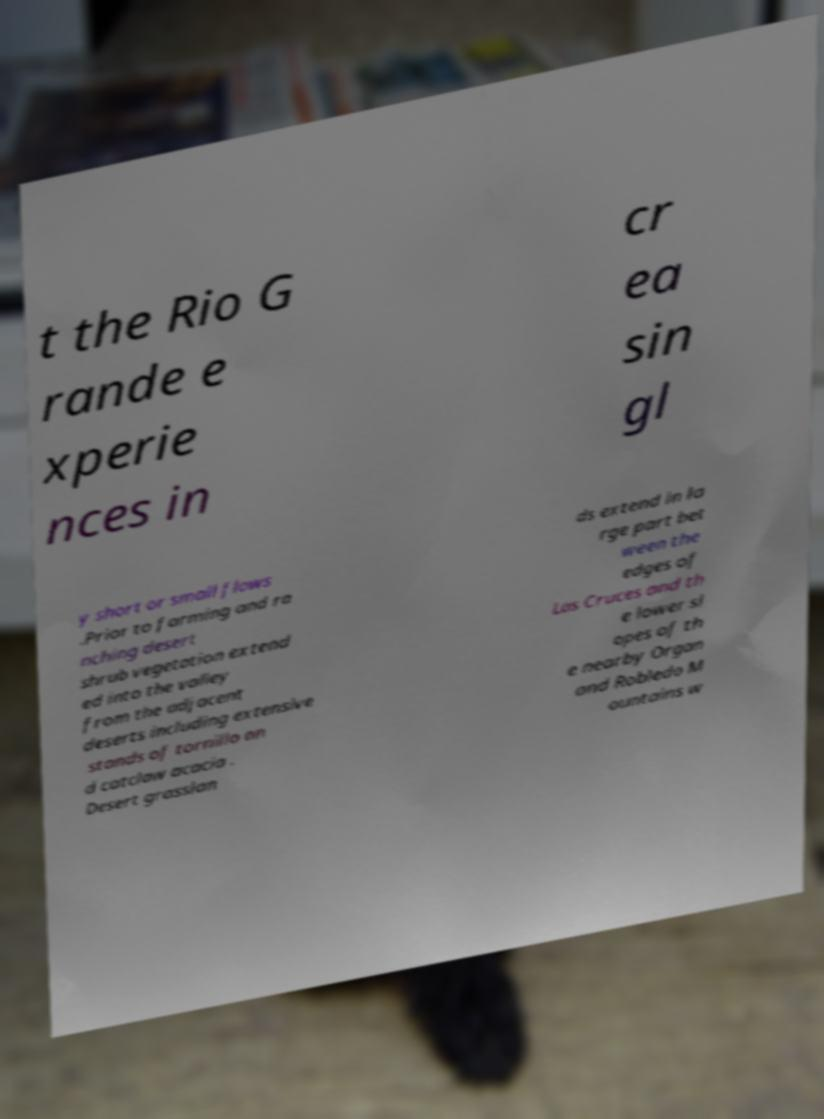I need the written content from this picture converted into text. Can you do that? t the Rio G rande e xperie nces in cr ea sin gl y short or small flows .Prior to farming and ra nching desert shrub vegetation extend ed into the valley from the adjacent deserts including extensive stands of tornillo an d catclaw acacia . Desert grasslan ds extend in la rge part bet ween the edges of Las Cruces and th e lower sl opes of th e nearby Organ and Robledo M ountains w 